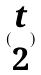Convert formula to latex. <formula><loc_0><loc_0><loc_500><loc_500>( \begin{matrix} t \\ 2 \end{matrix} )</formula> 